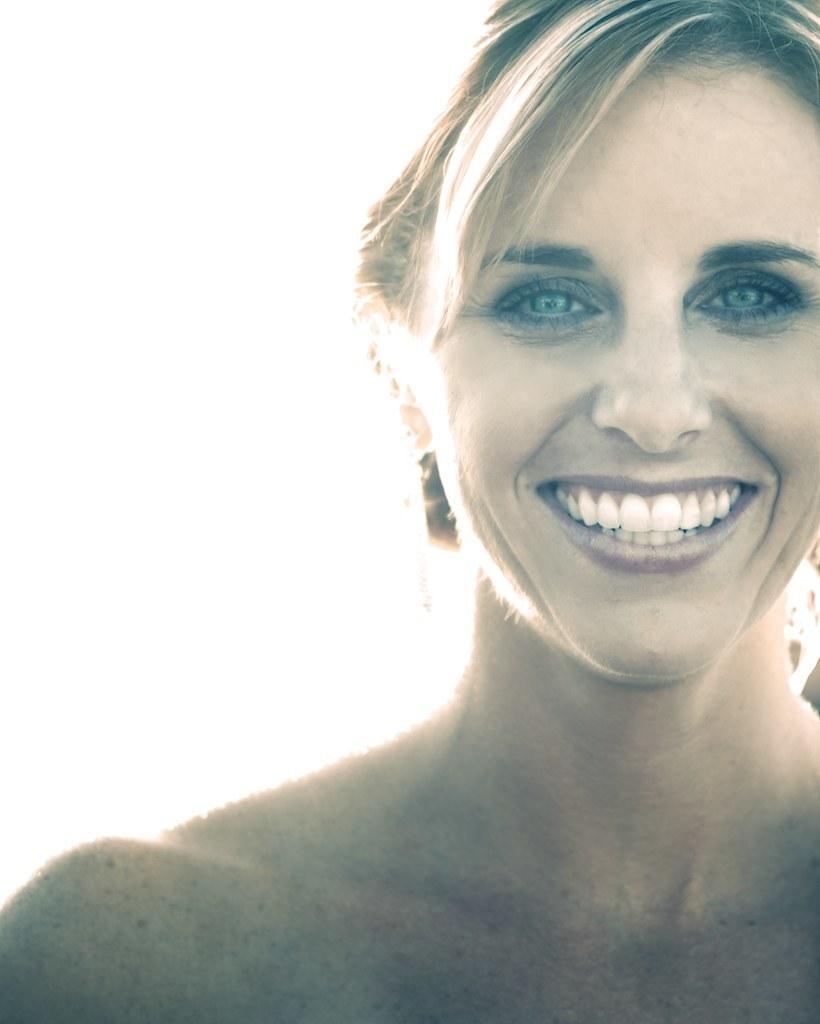How would you summarize this image in a sentence or two? In this image we can see a woman and she is smiling. There is a white background. 